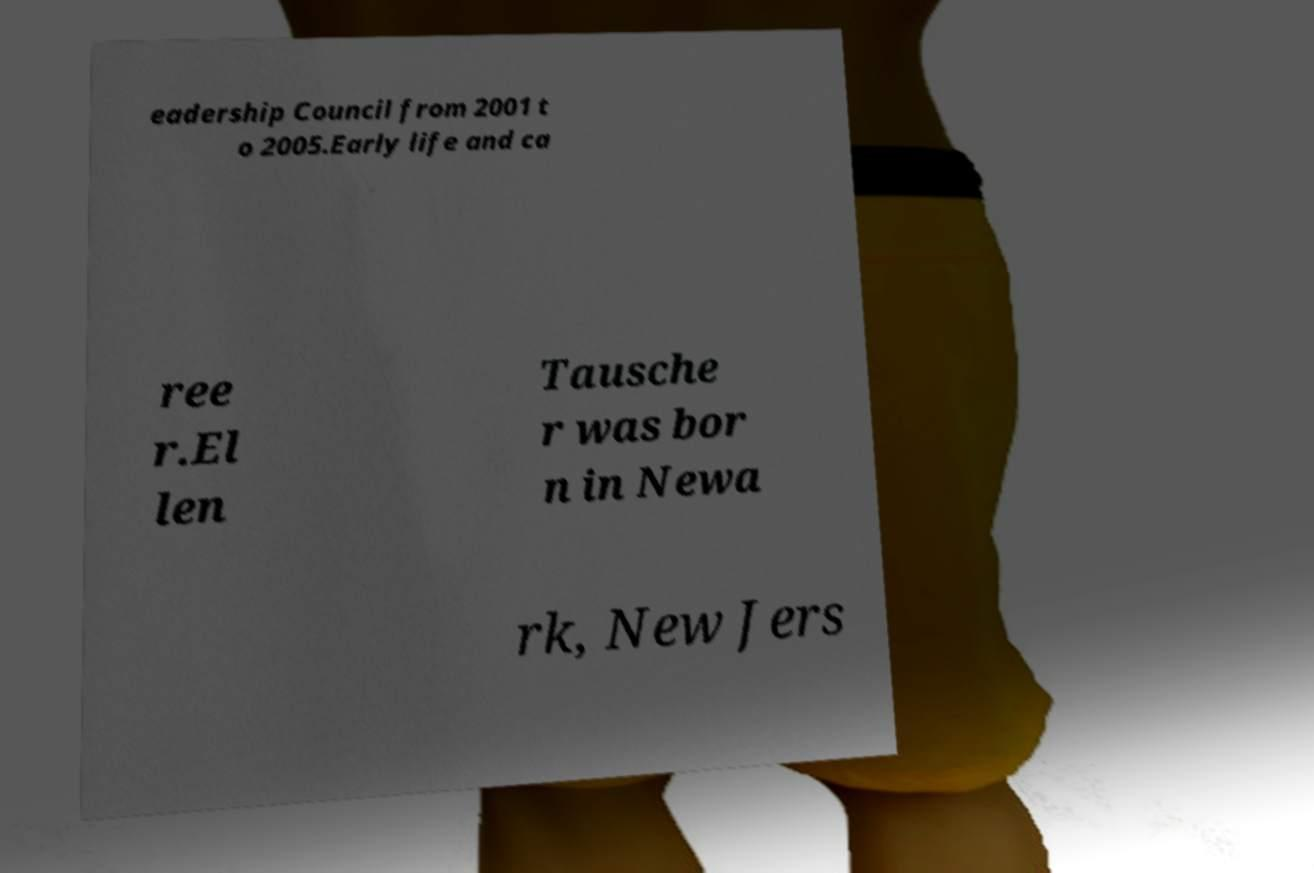Could you assist in decoding the text presented in this image and type it out clearly? eadership Council from 2001 t o 2005.Early life and ca ree r.El len Tausche r was bor n in Newa rk, New Jers 